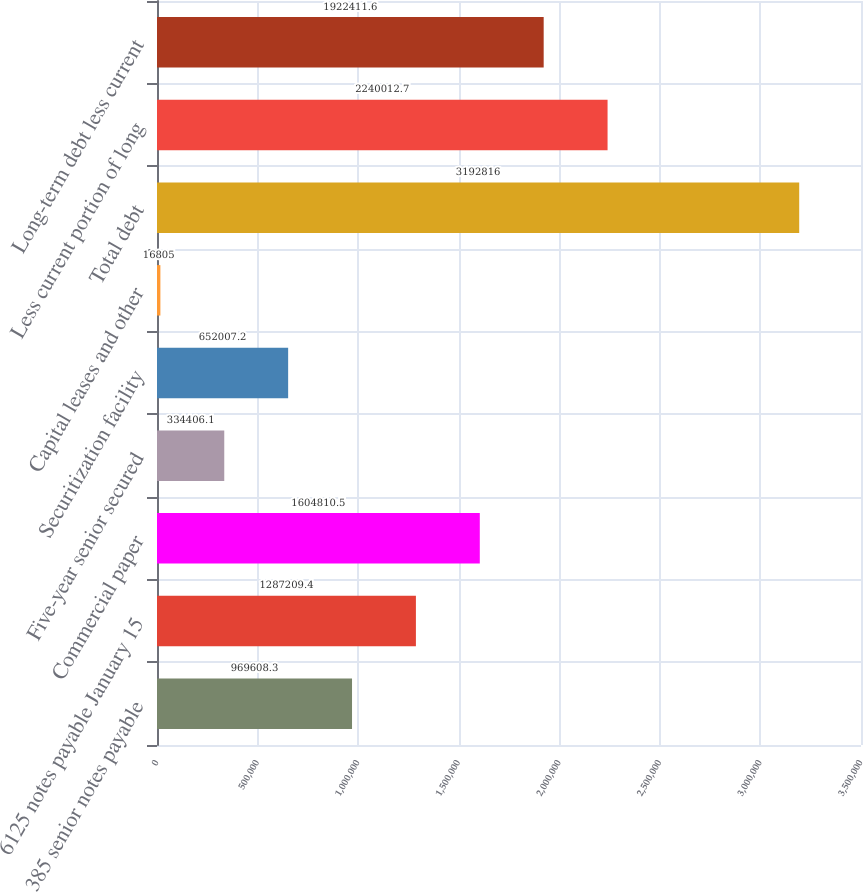Convert chart. <chart><loc_0><loc_0><loc_500><loc_500><bar_chart><fcel>385 senior notes payable<fcel>6125 notes payable January 15<fcel>Commercial paper<fcel>Five-year senior secured<fcel>Securitization facility<fcel>Capital leases and other<fcel>Total debt<fcel>Less current portion of long<fcel>Long-term debt less current<nl><fcel>969608<fcel>1.28721e+06<fcel>1.60481e+06<fcel>334406<fcel>652007<fcel>16805<fcel>3.19282e+06<fcel>2.24001e+06<fcel>1.92241e+06<nl></chart> 